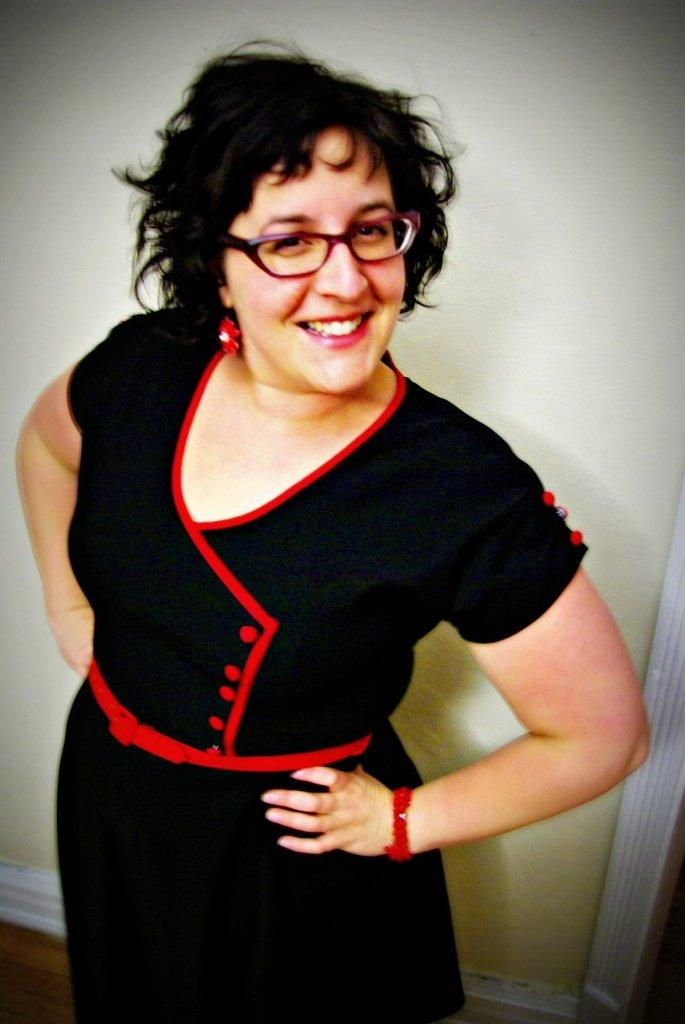Who is the main subject in the image? There is a woman in the image. What is the woman doing in the image? The woman is watching and smiling. What can be seen in the background of the image? There is a wall in the background of the image. Where is the wooden floor visible in the image? The wooden floor is visible in the left side bottom corner of the image. How many beggars are present in the image? There are no beggars present in the image; it features a woman watching and smiling. What type of flesh can be seen on the woman's face in the image? There is no flesh visible on the woman's face in the image; it is a photograph, not a medical scan. 